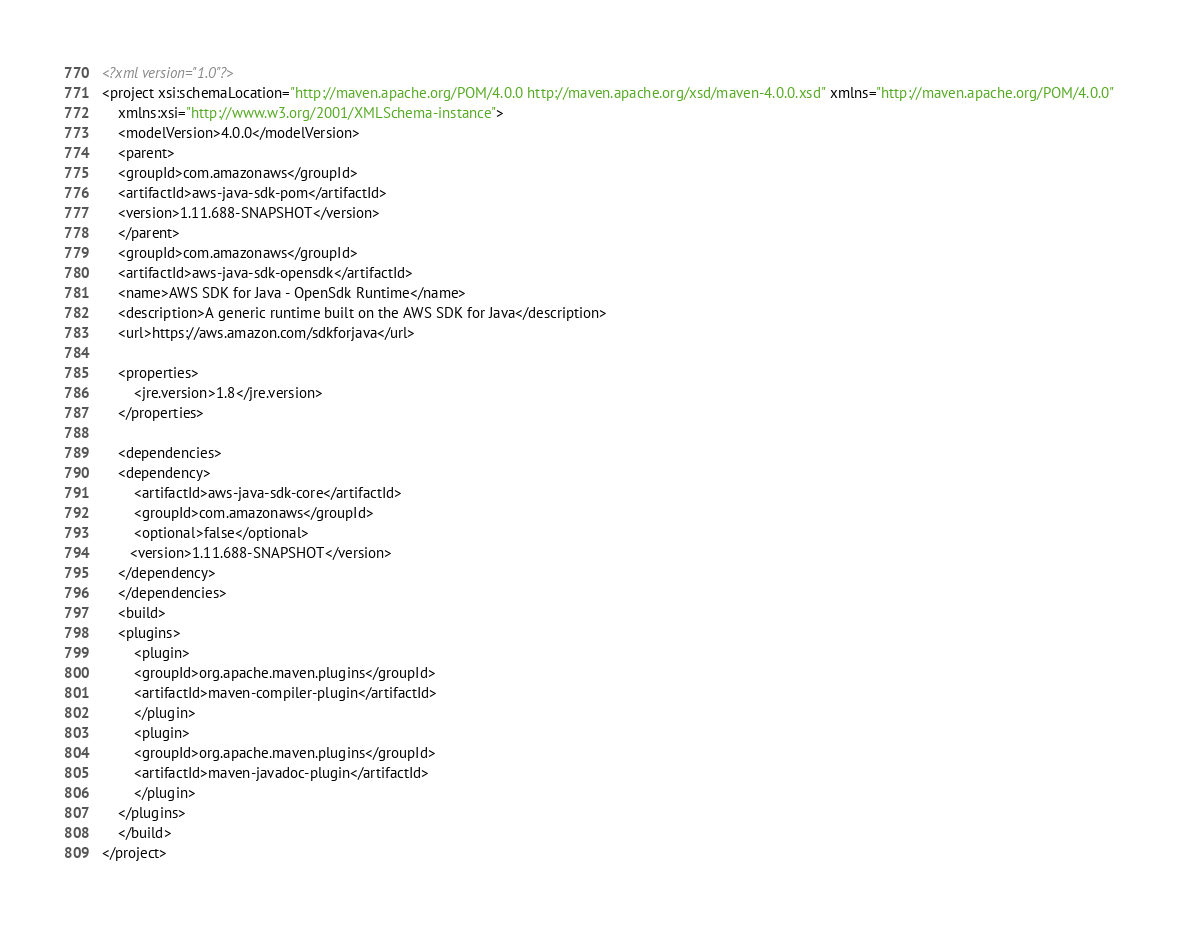<code> <loc_0><loc_0><loc_500><loc_500><_XML_><?xml version="1.0"?>
<project xsi:schemaLocation="http://maven.apache.org/POM/4.0.0 http://maven.apache.org/xsd/maven-4.0.0.xsd" xmlns="http://maven.apache.org/POM/4.0.0"
    xmlns:xsi="http://www.w3.org/2001/XMLSchema-instance">
    <modelVersion>4.0.0</modelVersion>
    <parent>
	<groupId>com.amazonaws</groupId>
	<artifactId>aws-java-sdk-pom</artifactId>
	<version>1.11.688-SNAPSHOT</version>
    </parent>
    <groupId>com.amazonaws</groupId>
    <artifactId>aws-java-sdk-opensdk</artifactId>
    <name>AWS SDK for Java - OpenSdk Runtime</name>
    <description>A generic runtime built on the AWS SDK for Java</description>
    <url>https://aws.amazon.com/sdkforjava</url>

    <properties>
        <jre.version>1.8</jre.version>
    </properties>

    <dependencies>
	<dependency>
	    <artifactId>aws-java-sdk-core</artifactId>
	    <groupId>com.amazonaws</groupId>
	    <optional>false</optional>
	   <version>1.11.688-SNAPSHOT</version>
	</dependency>
    </dependencies>
    <build>
	<plugins>
	    <plugin>
		<groupId>org.apache.maven.plugins</groupId>
		<artifactId>maven-compiler-plugin</artifactId>
	    </plugin>
	    <plugin>
		<groupId>org.apache.maven.plugins</groupId>
		<artifactId>maven-javadoc-plugin</artifactId>
	    </plugin>
	</plugins>
    </build>
</project>
</code> 